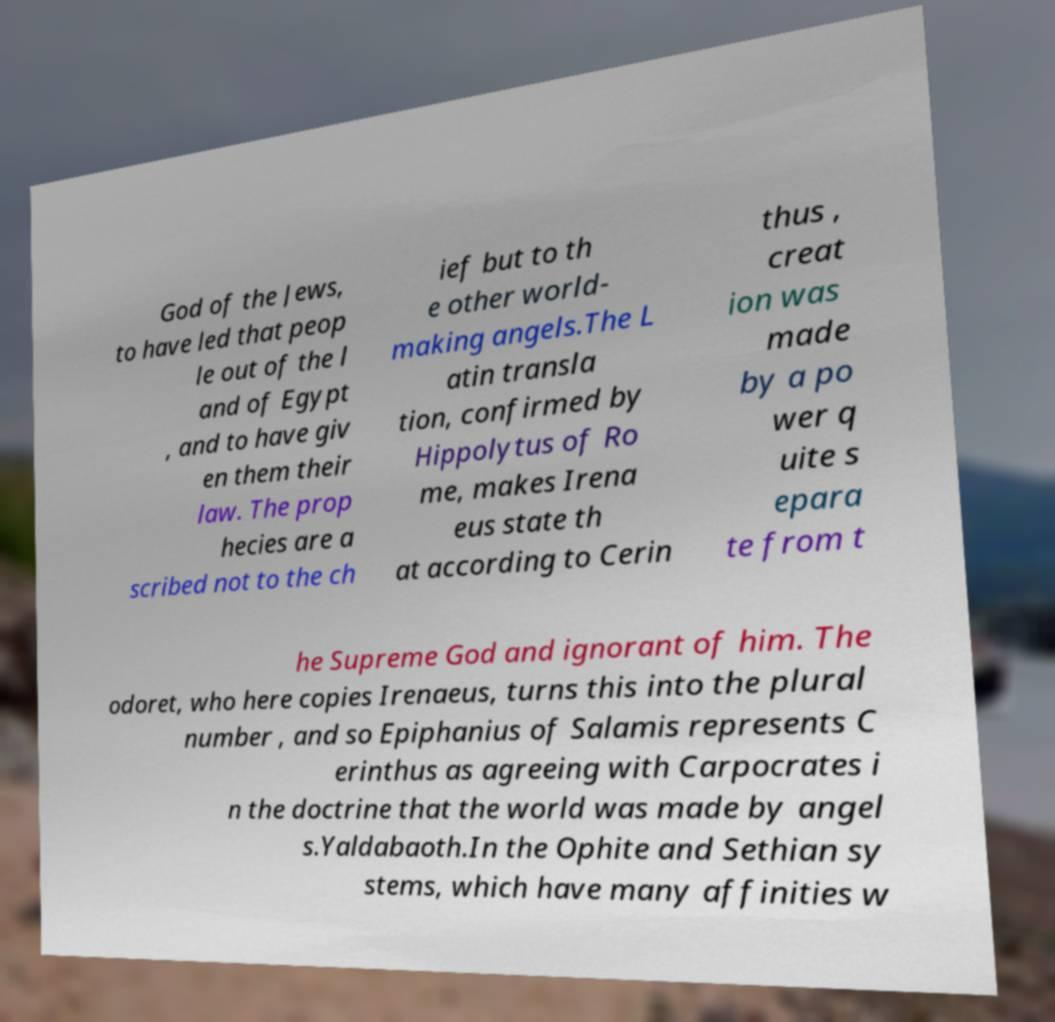There's text embedded in this image that I need extracted. Can you transcribe it verbatim? God of the Jews, to have led that peop le out of the l and of Egypt , and to have giv en them their law. The prop hecies are a scribed not to the ch ief but to th e other world- making angels.The L atin transla tion, confirmed by Hippolytus of Ro me, makes Irena eus state th at according to Cerin thus , creat ion was made by a po wer q uite s epara te from t he Supreme God and ignorant of him. The odoret, who here copies Irenaeus, turns this into the plural number , and so Epiphanius of Salamis represents C erinthus as agreeing with Carpocrates i n the doctrine that the world was made by angel s.Yaldabaoth.In the Ophite and Sethian sy stems, which have many affinities w 